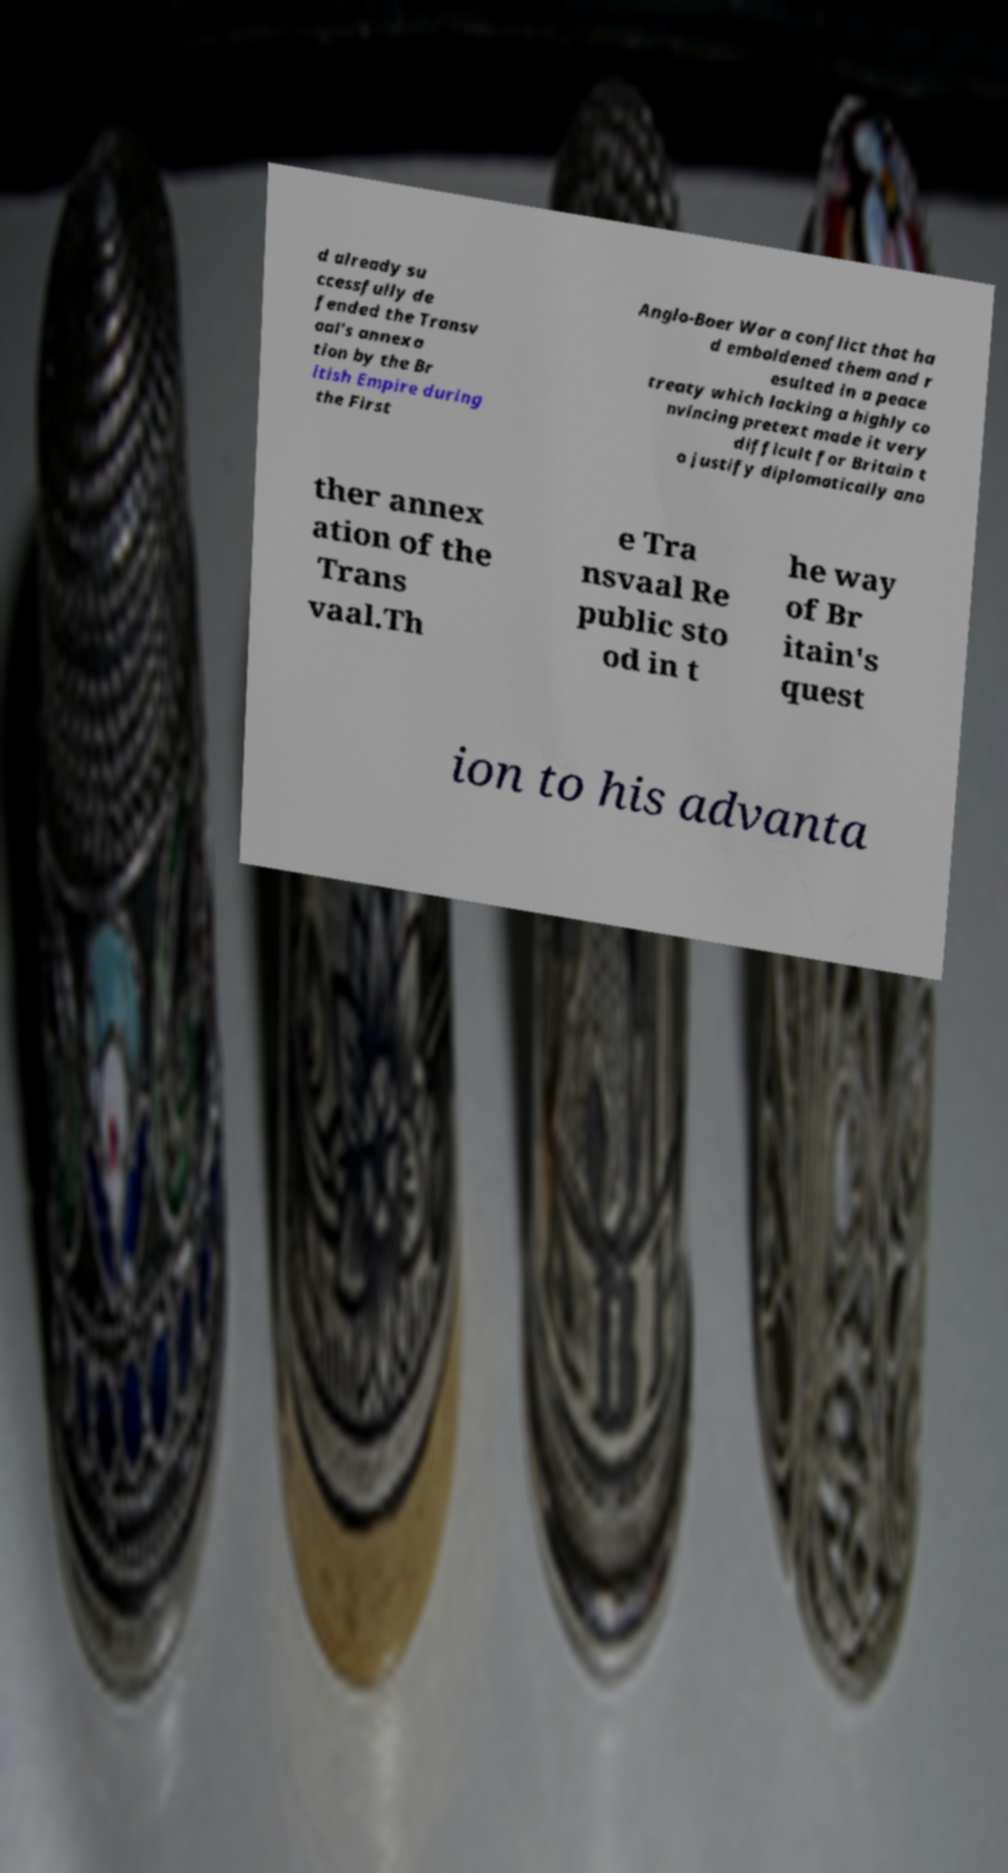Can you accurately transcribe the text from the provided image for me? d already su ccessfully de fended the Transv aal's annexa tion by the Br itish Empire during the First Anglo-Boer War a conflict that ha d emboldened them and r esulted in a peace treaty which lacking a highly co nvincing pretext made it very difficult for Britain t o justify diplomatically ano ther annex ation of the Trans vaal.Th e Tra nsvaal Re public sto od in t he way of Br itain's quest ion to his advanta 